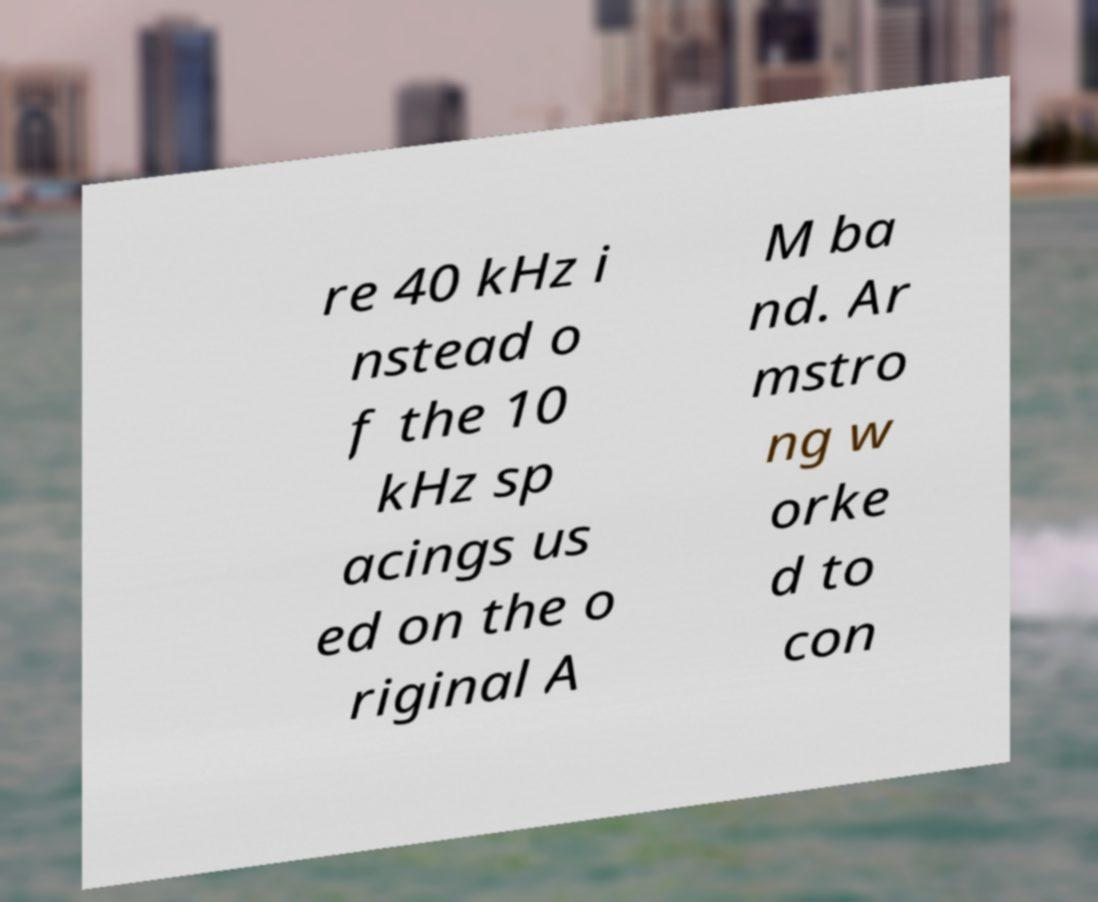Can you read and provide the text displayed in the image?This photo seems to have some interesting text. Can you extract and type it out for me? re 40 kHz i nstead o f the 10 kHz sp acings us ed on the o riginal A M ba nd. Ar mstro ng w orke d to con 